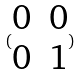Convert formula to latex. <formula><loc_0><loc_0><loc_500><loc_500>( \begin{matrix} 0 & 0 \\ 0 & 1 \end{matrix} )</formula> 